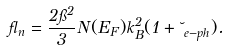<formula> <loc_0><loc_0><loc_500><loc_500>\gamma _ { n } = \frac { 2 \pi ^ { 2 } } { 3 } N ( E _ { F } ) k _ { B } ^ { 2 } ( 1 + \lambda _ { e - p h } ) .</formula> 